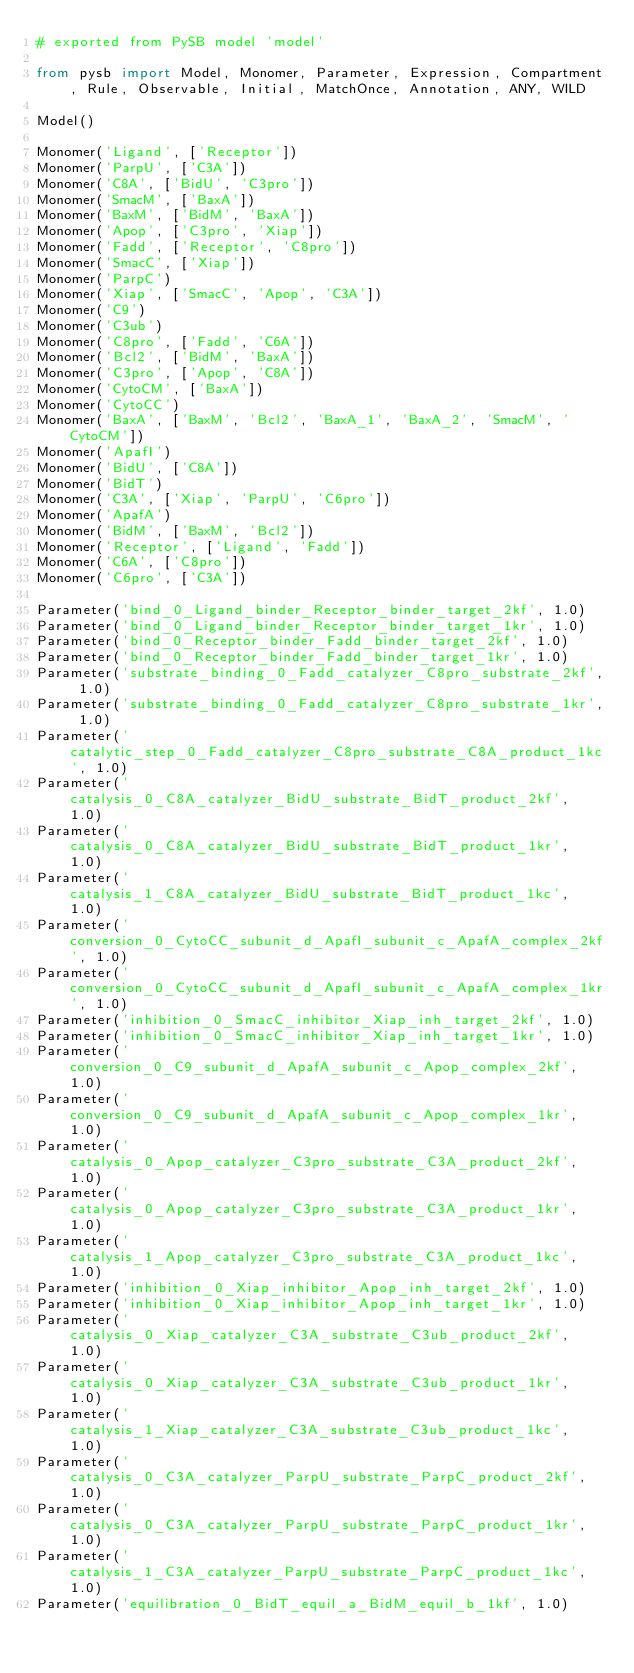<code> <loc_0><loc_0><loc_500><loc_500><_Python_># exported from PySB model 'model'

from pysb import Model, Monomer, Parameter, Expression, Compartment, Rule, Observable, Initial, MatchOnce, Annotation, ANY, WILD

Model()

Monomer('Ligand', ['Receptor'])
Monomer('ParpU', ['C3A'])
Monomer('C8A', ['BidU', 'C3pro'])
Monomer('SmacM', ['BaxA'])
Monomer('BaxM', ['BidM', 'BaxA'])
Monomer('Apop', ['C3pro', 'Xiap'])
Monomer('Fadd', ['Receptor', 'C8pro'])
Monomer('SmacC', ['Xiap'])
Monomer('ParpC')
Monomer('Xiap', ['SmacC', 'Apop', 'C3A'])
Monomer('C9')
Monomer('C3ub')
Monomer('C8pro', ['Fadd', 'C6A'])
Monomer('Bcl2', ['BidM', 'BaxA'])
Monomer('C3pro', ['Apop', 'C8A'])
Monomer('CytoCM', ['BaxA'])
Monomer('CytoCC')
Monomer('BaxA', ['BaxM', 'Bcl2', 'BaxA_1', 'BaxA_2', 'SmacM', 'CytoCM'])
Monomer('ApafI')
Monomer('BidU', ['C8A'])
Monomer('BidT')
Monomer('C3A', ['Xiap', 'ParpU', 'C6pro'])
Monomer('ApafA')
Monomer('BidM', ['BaxM', 'Bcl2'])
Monomer('Receptor', ['Ligand', 'Fadd'])
Monomer('C6A', ['C8pro'])
Monomer('C6pro', ['C3A'])

Parameter('bind_0_Ligand_binder_Receptor_binder_target_2kf', 1.0)
Parameter('bind_0_Ligand_binder_Receptor_binder_target_1kr', 1.0)
Parameter('bind_0_Receptor_binder_Fadd_binder_target_2kf', 1.0)
Parameter('bind_0_Receptor_binder_Fadd_binder_target_1kr', 1.0)
Parameter('substrate_binding_0_Fadd_catalyzer_C8pro_substrate_2kf', 1.0)
Parameter('substrate_binding_0_Fadd_catalyzer_C8pro_substrate_1kr', 1.0)
Parameter('catalytic_step_0_Fadd_catalyzer_C8pro_substrate_C8A_product_1kc', 1.0)
Parameter('catalysis_0_C8A_catalyzer_BidU_substrate_BidT_product_2kf', 1.0)
Parameter('catalysis_0_C8A_catalyzer_BidU_substrate_BidT_product_1kr', 1.0)
Parameter('catalysis_1_C8A_catalyzer_BidU_substrate_BidT_product_1kc', 1.0)
Parameter('conversion_0_CytoCC_subunit_d_ApafI_subunit_c_ApafA_complex_2kf', 1.0)
Parameter('conversion_0_CytoCC_subunit_d_ApafI_subunit_c_ApafA_complex_1kr', 1.0)
Parameter('inhibition_0_SmacC_inhibitor_Xiap_inh_target_2kf', 1.0)
Parameter('inhibition_0_SmacC_inhibitor_Xiap_inh_target_1kr', 1.0)
Parameter('conversion_0_C9_subunit_d_ApafA_subunit_c_Apop_complex_2kf', 1.0)
Parameter('conversion_0_C9_subunit_d_ApafA_subunit_c_Apop_complex_1kr', 1.0)
Parameter('catalysis_0_Apop_catalyzer_C3pro_substrate_C3A_product_2kf', 1.0)
Parameter('catalysis_0_Apop_catalyzer_C3pro_substrate_C3A_product_1kr', 1.0)
Parameter('catalysis_1_Apop_catalyzer_C3pro_substrate_C3A_product_1kc', 1.0)
Parameter('inhibition_0_Xiap_inhibitor_Apop_inh_target_2kf', 1.0)
Parameter('inhibition_0_Xiap_inhibitor_Apop_inh_target_1kr', 1.0)
Parameter('catalysis_0_Xiap_catalyzer_C3A_substrate_C3ub_product_2kf', 1.0)
Parameter('catalysis_0_Xiap_catalyzer_C3A_substrate_C3ub_product_1kr', 1.0)
Parameter('catalysis_1_Xiap_catalyzer_C3A_substrate_C3ub_product_1kc', 1.0)
Parameter('catalysis_0_C3A_catalyzer_ParpU_substrate_ParpC_product_2kf', 1.0)
Parameter('catalysis_0_C3A_catalyzer_ParpU_substrate_ParpC_product_1kr', 1.0)
Parameter('catalysis_1_C3A_catalyzer_ParpU_substrate_ParpC_product_1kc', 1.0)
Parameter('equilibration_0_BidT_equil_a_BidM_equil_b_1kf', 1.0)</code> 